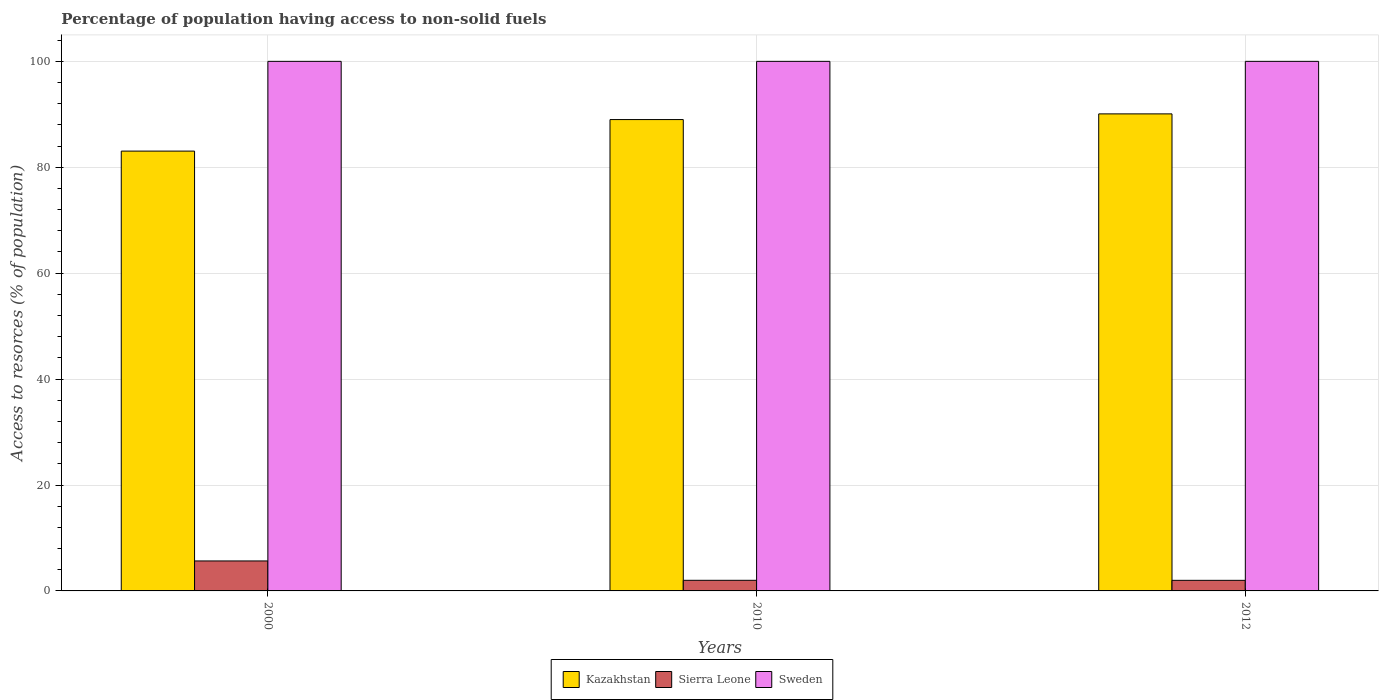How many different coloured bars are there?
Make the answer very short. 3. How many groups of bars are there?
Keep it short and to the point. 3. Are the number of bars on each tick of the X-axis equal?
Your answer should be very brief. Yes. What is the label of the 2nd group of bars from the left?
Give a very brief answer. 2010. In how many cases, is the number of bars for a given year not equal to the number of legend labels?
Your answer should be compact. 0. What is the percentage of population having access to non-solid fuels in Kazakhstan in 2000?
Your answer should be compact. 83.05. Across all years, what is the maximum percentage of population having access to non-solid fuels in Kazakhstan?
Give a very brief answer. 90.08. Across all years, what is the minimum percentage of population having access to non-solid fuels in Sweden?
Your answer should be compact. 100. In which year was the percentage of population having access to non-solid fuels in Kazakhstan maximum?
Provide a short and direct response. 2012. What is the total percentage of population having access to non-solid fuels in Sierra Leone in the graph?
Your answer should be very brief. 9.67. What is the difference between the percentage of population having access to non-solid fuels in Sweden in 2010 and that in 2012?
Ensure brevity in your answer.  0. What is the difference between the percentage of population having access to non-solid fuels in Sierra Leone in 2000 and the percentage of population having access to non-solid fuels in Kazakhstan in 2012?
Your answer should be compact. -84.42. In the year 2012, what is the difference between the percentage of population having access to non-solid fuels in Sweden and percentage of population having access to non-solid fuels in Kazakhstan?
Your answer should be compact. 9.92. What is the ratio of the percentage of population having access to non-solid fuels in Sierra Leone in 2000 to that in 2012?
Provide a succinct answer. 2.83. Is the percentage of population having access to non-solid fuels in Kazakhstan in 2000 less than that in 2010?
Give a very brief answer. Yes. Is the difference between the percentage of population having access to non-solid fuels in Sweden in 2010 and 2012 greater than the difference between the percentage of population having access to non-solid fuels in Kazakhstan in 2010 and 2012?
Offer a terse response. Yes. What is the difference between the highest and the second highest percentage of population having access to non-solid fuels in Sierra Leone?
Make the answer very short. 3.66. What is the difference between the highest and the lowest percentage of population having access to non-solid fuels in Kazakhstan?
Ensure brevity in your answer.  7.03. In how many years, is the percentage of population having access to non-solid fuels in Kazakhstan greater than the average percentage of population having access to non-solid fuels in Kazakhstan taken over all years?
Your answer should be compact. 2. What does the 1st bar from the left in 2010 represents?
Offer a terse response. Kazakhstan. What does the 3rd bar from the right in 2000 represents?
Provide a succinct answer. Kazakhstan. Is it the case that in every year, the sum of the percentage of population having access to non-solid fuels in Sweden and percentage of population having access to non-solid fuels in Sierra Leone is greater than the percentage of population having access to non-solid fuels in Kazakhstan?
Give a very brief answer. Yes. How many bars are there?
Ensure brevity in your answer.  9. What is the difference between two consecutive major ticks on the Y-axis?
Make the answer very short. 20. Are the values on the major ticks of Y-axis written in scientific E-notation?
Offer a terse response. No. Does the graph contain any zero values?
Your response must be concise. No. Does the graph contain grids?
Your answer should be compact. Yes. How many legend labels are there?
Give a very brief answer. 3. What is the title of the graph?
Keep it short and to the point. Percentage of population having access to non-solid fuels. What is the label or title of the Y-axis?
Keep it short and to the point. Access to resorces (% of population). What is the Access to resorces (% of population) of Kazakhstan in 2000?
Make the answer very short. 83.05. What is the Access to resorces (% of population) of Sierra Leone in 2000?
Your response must be concise. 5.66. What is the Access to resorces (% of population) in Kazakhstan in 2010?
Provide a short and direct response. 89.01. What is the Access to resorces (% of population) in Sierra Leone in 2010?
Your answer should be very brief. 2. What is the Access to resorces (% of population) in Sweden in 2010?
Provide a short and direct response. 100. What is the Access to resorces (% of population) of Kazakhstan in 2012?
Offer a very short reply. 90.08. What is the Access to resorces (% of population) of Sierra Leone in 2012?
Your response must be concise. 2. Across all years, what is the maximum Access to resorces (% of population) of Kazakhstan?
Make the answer very short. 90.08. Across all years, what is the maximum Access to resorces (% of population) in Sierra Leone?
Keep it short and to the point. 5.66. Across all years, what is the maximum Access to resorces (% of population) in Sweden?
Keep it short and to the point. 100. Across all years, what is the minimum Access to resorces (% of population) of Kazakhstan?
Your answer should be very brief. 83.05. Across all years, what is the minimum Access to resorces (% of population) in Sierra Leone?
Offer a very short reply. 2. What is the total Access to resorces (% of population) in Kazakhstan in the graph?
Your answer should be compact. 262.14. What is the total Access to resorces (% of population) of Sierra Leone in the graph?
Offer a very short reply. 9.67. What is the total Access to resorces (% of population) in Sweden in the graph?
Keep it short and to the point. 300. What is the difference between the Access to resorces (% of population) in Kazakhstan in 2000 and that in 2010?
Make the answer very short. -5.95. What is the difference between the Access to resorces (% of population) in Sierra Leone in 2000 and that in 2010?
Your answer should be very brief. 3.66. What is the difference between the Access to resorces (% of population) of Sweden in 2000 and that in 2010?
Your answer should be very brief. 0. What is the difference between the Access to resorces (% of population) in Kazakhstan in 2000 and that in 2012?
Offer a very short reply. -7.03. What is the difference between the Access to resorces (% of population) of Sierra Leone in 2000 and that in 2012?
Offer a terse response. 3.66. What is the difference between the Access to resorces (% of population) in Sweden in 2000 and that in 2012?
Offer a very short reply. 0. What is the difference between the Access to resorces (% of population) of Kazakhstan in 2010 and that in 2012?
Your answer should be very brief. -1.08. What is the difference between the Access to resorces (% of population) in Sierra Leone in 2010 and that in 2012?
Your response must be concise. 0. What is the difference between the Access to resorces (% of population) in Sweden in 2010 and that in 2012?
Keep it short and to the point. 0. What is the difference between the Access to resorces (% of population) in Kazakhstan in 2000 and the Access to resorces (% of population) in Sierra Leone in 2010?
Offer a terse response. 81.05. What is the difference between the Access to resorces (% of population) of Kazakhstan in 2000 and the Access to resorces (% of population) of Sweden in 2010?
Ensure brevity in your answer.  -16.95. What is the difference between the Access to resorces (% of population) of Sierra Leone in 2000 and the Access to resorces (% of population) of Sweden in 2010?
Your answer should be compact. -94.34. What is the difference between the Access to resorces (% of population) of Kazakhstan in 2000 and the Access to resorces (% of population) of Sierra Leone in 2012?
Your answer should be compact. 81.05. What is the difference between the Access to resorces (% of population) in Kazakhstan in 2000 and the Access to resorces (% of population) in Sweden in 2012?
Ensure brevity in your answer.  -16.95. What is the difference between the Access to resorces (% of population) in Sierra Leone in 2000 and the Access to resorces (% of population) in Sweden in 2012?
Keep it short and to the point. -94.34. What is the difference between the Access to resorces (% of population) in Kazakhstan in 2010 and the Access to resorces (% of population) in Sierra Leone in 2012?
Ensure brevity in your answer.  87.01. What is the difference between the Access to resorces (% of population) of Kazakhstan in 2010 and the Access to resorces (% of population) of Sweden in 2012?
Make the answer very short. -10.99. What is the difference between the Access to resorces (% of population) of Sierra Leone in 2010 and the Access to resorces (% of population) of Sweden in 2012?
Provide a short and direct response. -98. What is the average Access to resorces (% of population) of Kazakhstan per year?
Provide a succinct answer. 87.38. What is the average Access to resorces (% of population) in Sierra Leone per year?
Keep it short and to the point. 3.22. In the year 2000, what is the difference between the Access to resorces (% of population) of Kazakhstan and Access to resorces (% of population) of Sierra Leone?
Make the answer very short. 77.39. In the year 2000, what is the difference between the Access to resorces (% of population) of Kazakhstan and Access to resorces (% of population) of Sweden?
Keep it short and to the point. -16.95. In the year 2000, what is the difference between the Access to resorces (% of population) of Sierra Leone and Access to resorces (% of population) of Sweden?
Offer a terse response. -94.34. In the year 2010, what is the difference between the Access to resorces (% of population) in Kazakhstan and Access to resorces (% of population) in Sierra Leone?
Provide a succinct answer. 87. In the year 2010, what is the difference between the Access to resorces (% of population) of Kazakhstan and Access to resorces (% of population) of Sweden?
Make the answer very short. -10.99. In the year 2010, what is the difference between the Access to resorces (% of population) in Sierra Leone and Access to resorces (% of population) in Sweden?
Offer a terse response. -98. In the year 2012, what is the difference between the Access to resorces (% of population) in Kazakhstan and Access to resorces (% of population) in Sierra Leone?
Offer a terse response. 88.08. In the year 2012, what is the difference between the Access to resorces (% of population) of Kazakhstan and Access to resorces (% of population) of Sweden?
Make the answer very short. -9.92. In the year 2012, what is the difference between the Access to resorces (% of population) of Sierra Leone and Access to resorces (% of population) of Sweden?
Make the answer very short. -98. What is the ratio of the Access to resorces (% of population) in Kazakhstan in 2000 to that in 2010?
Your answer should be very brief. 0.93. What is the ratio of the Access to resorces (% of population) in Sierra Leone in 2000 to that in 2010?
Give a very brief answer. 2.82. What is the ratio of the Access to resorces (% of population) of Kazakhstan in 2000 to that in 2012?
Keep it short and to the point. 0.92. What is the ratio of the Access to resorces (% of population) in Sierra Leone in 2000 to that in 2012?
Ensure brevity in your answer.  2.83. What is the ratio of the Access to resorces (% of population) in Sierra Leone in 2010 to that in 2012?
Keep it short and to the point. 1. What is the difference between the highest and the second highest Access to resorces (% of population) in Kazakhstan?
Ensure brevity in your answer.  1.08. What is the difference between the highest and the second highest Access to resorces (% of population) of Sierra Leone?
Provide a succinct answer. 3.66. What is the difference between the highest and the lowest Access to resorces (% of population) of Kazakhstan?
Ensure brevity in your answer.  7.03. What is the difference between the highest and the lowest Access to resorces (% of population) in Sierra Leone?
Your answer should be compact. 3.66. 